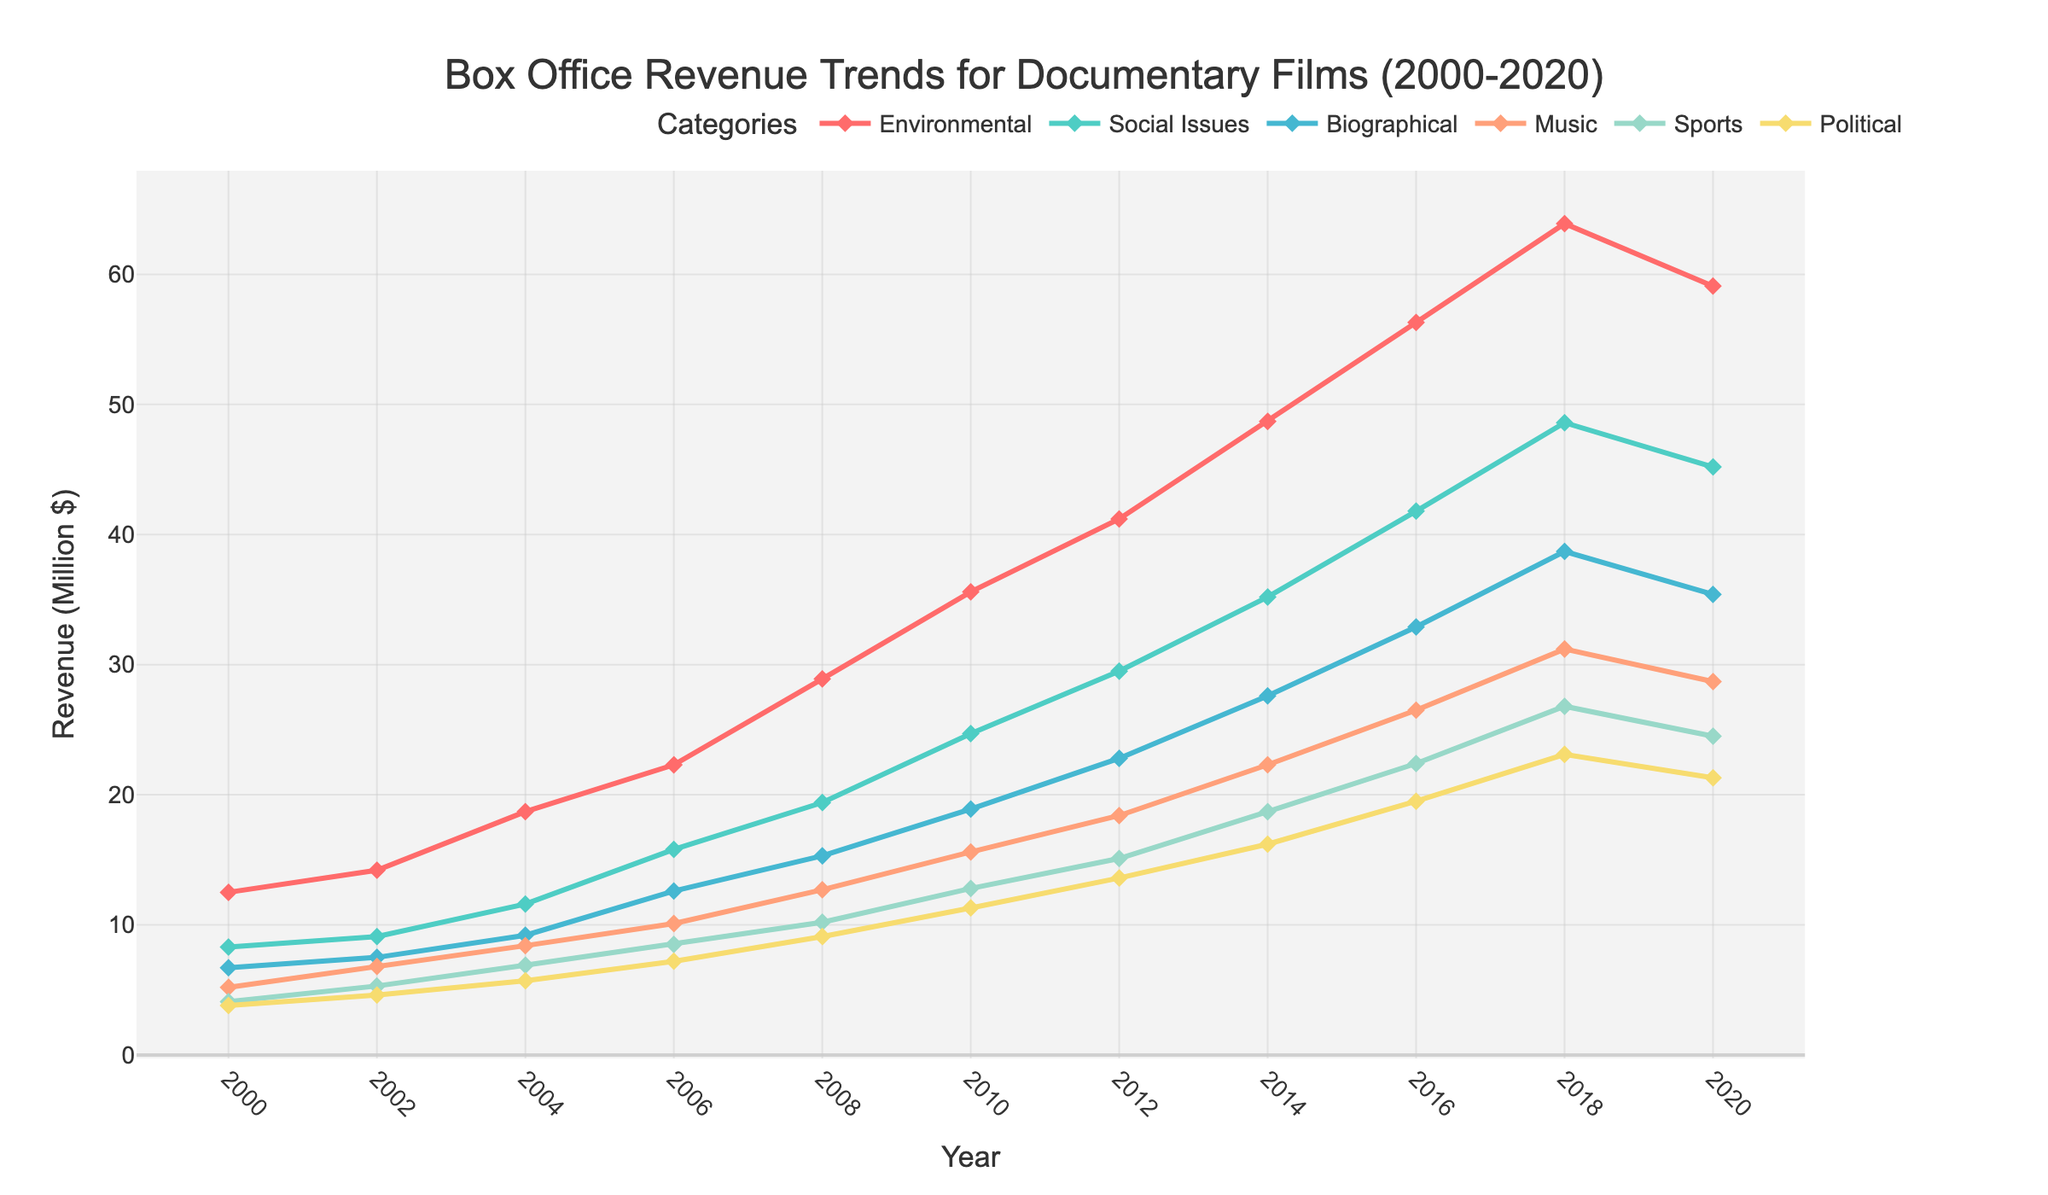What subject category had the highest box office revenue in 2020? Looking at the 2020 data points on the chart, the Environmental category has the highest box office revenue.
Answer: Environmental Which subject categories show a consistent increase in box office revenue from 2000 to 2018 but a decrease in 2020? Observing the lines, Social Issues and Biographical categories show a consistent rise till 2018 and a drop in 2020.
Answer: Social Issues, Biographical Between Environmental and Sports documentaries, which category saw a bigger absolute increase in box office revenue from 2006 to 2010? For Environmental, the increase from 22.3 to 35.6 is 13.3 million. For Sports, the increase from 8.5 to 12.8 is 4.3 million. The Environmental category saw a larger increase.
Answer: Environmental What is the average box office revenue for Music documentaries over the two-decade period? Summing up the revenues for Music from 2000 to 2020 gives (5.2 + 6.8 + 8.4 + 10.1 + 12.7 + 15.6 + 18.4 + 22.3 + 26.5 + 31.2 + 28.7) = 186.9. There are 11 data points, so the average is 186.9/11 ≈ 17.0 million.
Answer: 17.0 million Which category has the steepest increase in box office revenue from 2000 to 2008? Comparing the slopes visually from 2000 to 2008, Environmental has the steepest increase as it rises from 12.5 to 28.9, which is a 16.4 million increase, steeper than other categories.
Answer: Environmental By what percentage did Political documentaries' box office revenue grow from 2000 to 2020? Political documentaries grew from 3.8 in 2000 to 21.3 in 2020. The percentage increase is ((21.3 - 3.8) / 3.8) * 100 ≈ 461.84%.
Answer: 461.84% Which year saw the highest combined box office revenue for all categories? Adding the revenues for all categories for each year, the highest total is in 2018 where the sums are (63.9 + 48.6 + 38.7 + 31.2 + 26.8 + 23.1) = 232.3 million.
Answer: 2018 What trend do you observe in the box office revenue for Biographical documentaries over the two-decade period? Biographical documentaries show a consistent upward trend from 6.7 in 2000 to 38.7 in 2018, then a slight drop to 35.4 in 2020.
Answer: Upward with slight drop in 2020 Which category had the smallest box office revenue increase from 2002 to 2004? Finding the differences from 2002 to 2004, the smallest increase is for Political documentaries with an increase of 1.1 (from 4.6 to 5.7).
Answer: Political 